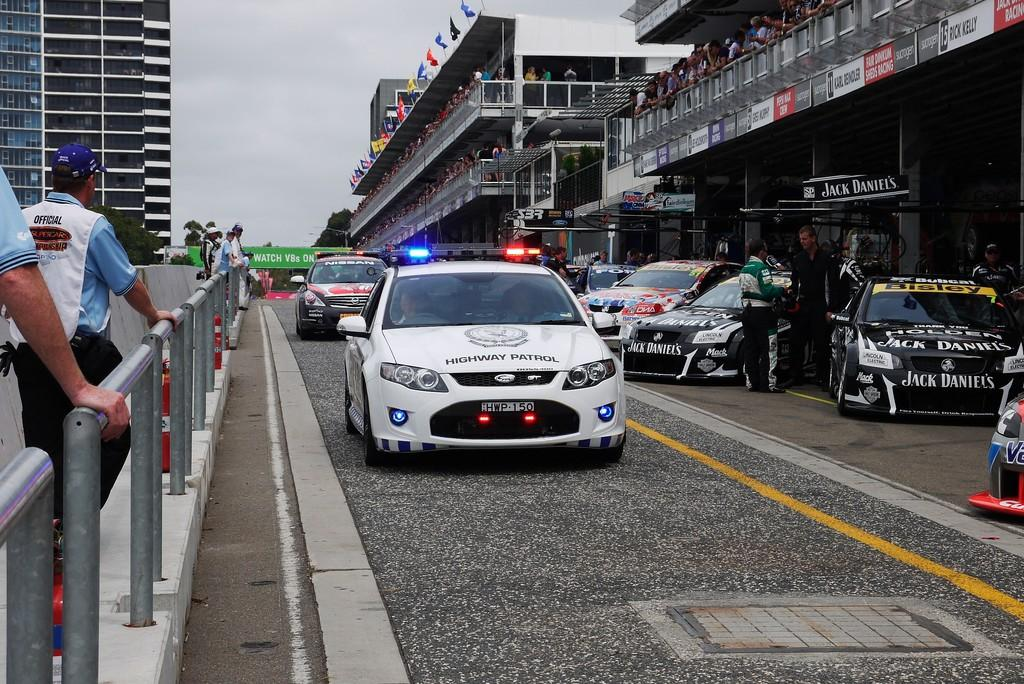Who or what can be seen in the image? There are people in the image. What else is present in the image besides people? There are cars, buildings, flags, trees, and the sky are visible in the image. What type of glue is being used to attach the canvas to the moon in the image? There is no canvas or moon present in the image, and therefore no glue or attachment process can be observed. 